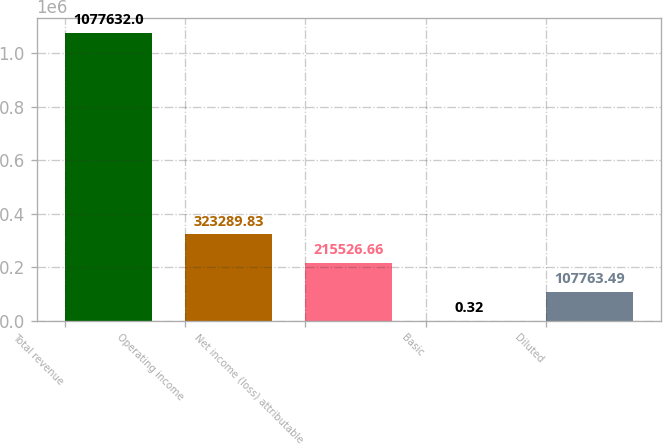Convert chart. <chart><loc_0><loc_0><loc_500><loc_500><bar_chart><fcel>Total revenue<fcel>Operating income<fcel>Net income (loss) attributable<fcel>Basic<fcel>Diluted<nl><fcel>1.07763e+06<fcel>323290<fcel>215527<fcel>0.32<fcel>107763<nl></chart> 